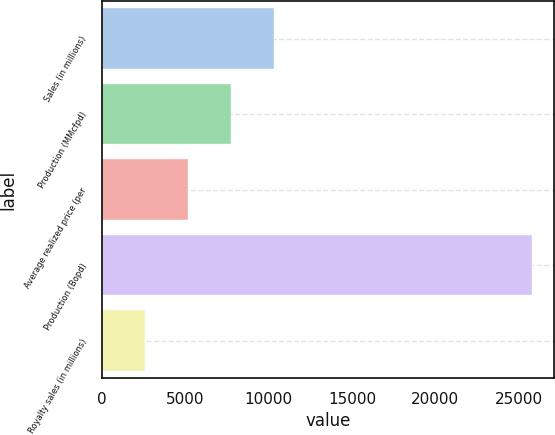Convert chart. <chart><loc_0><loc_0><loc_500><loc_500><bar_chart><fcel>Sales (in millions)<fcel>Production (MMcfpd)<fcel>Average realized price (per<fcel>Production (Bopd)<fcel>Royalty sales (in millions)<nl><fcel>10324.3<fcel>7744.16<fcel>5164.04<fcel>25805<fcel>2583.92<nl></chart> 